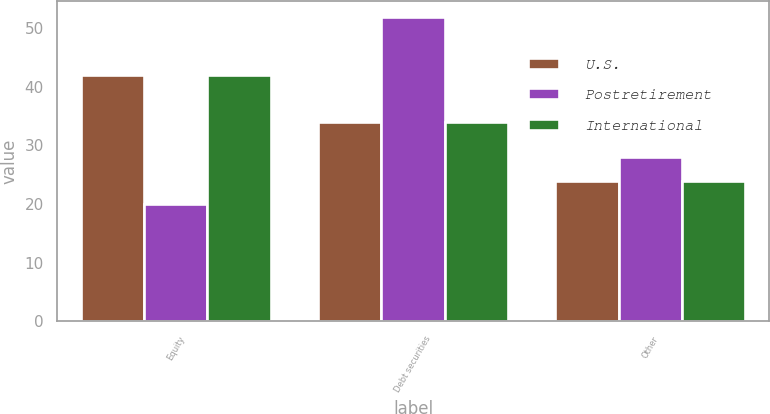Convert chart. <chart><loc_0><loc_0><loc_500><loc_500><stacked_bar_chart><ecel><fcel>Equity<fcel>Debt securities<fcel>Other<nl><fcel>U.S.<fcel>42<fcel>34<fcel>24<nl><fcel>Postretirement<fcel>20<fcel>52<fcel>28<nl><fcel>International<fcel>42<fcel>34<fcel>24<nl></chart> 